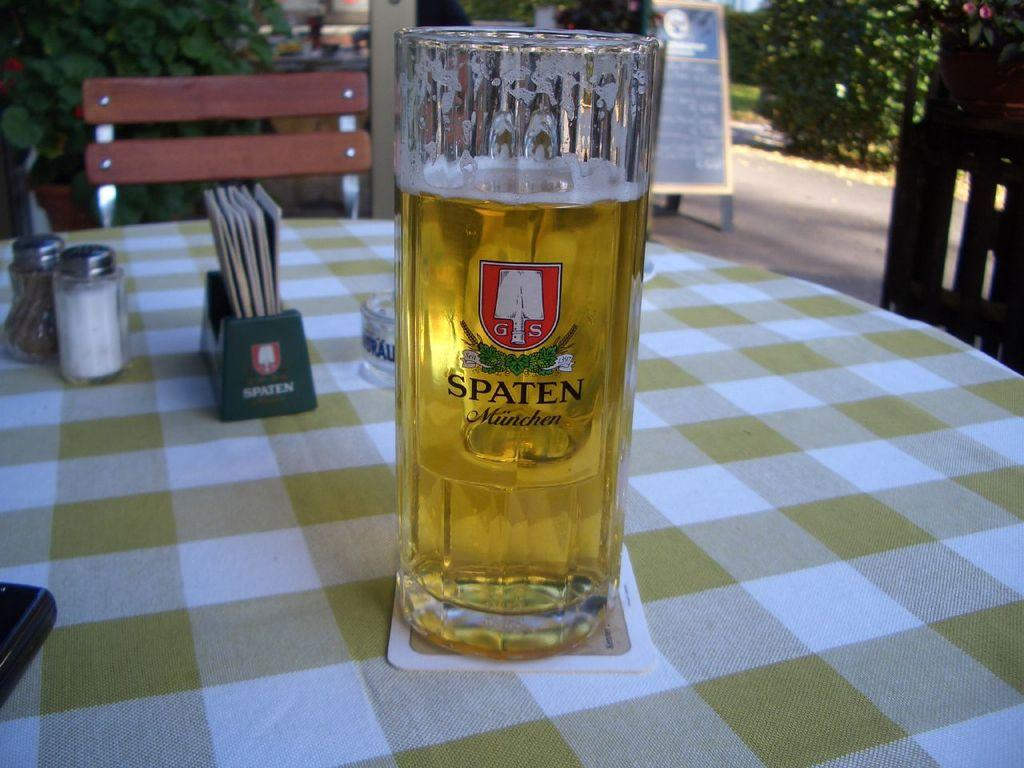<image>
Describe the image concisely. A glass of beer that says Spaten placed on a table. 